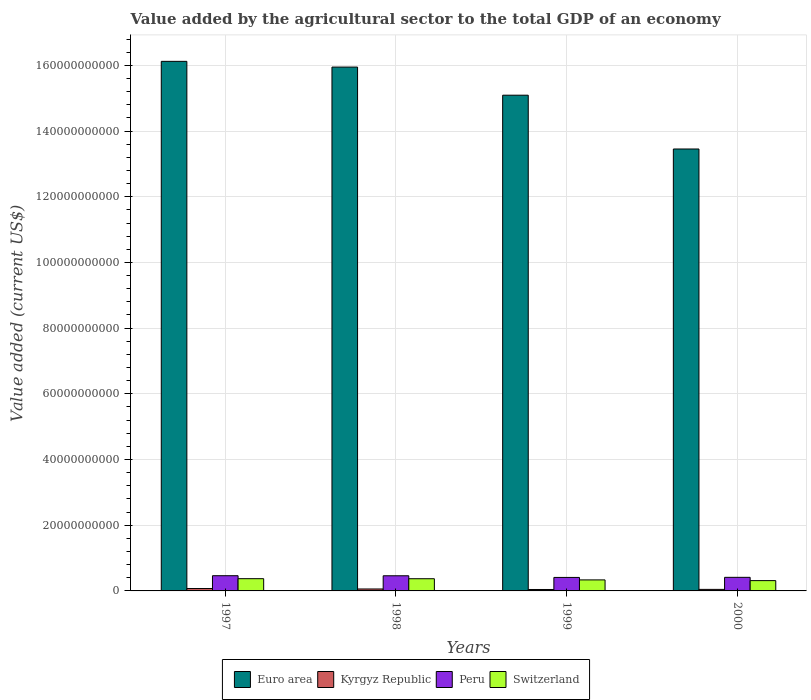How many different coloured bars are there?
Provide a short and direct response. 4. How many groups of bars are there?
Your answer should be very brief. 4. Are the number of bars on each tick of the X-axis equal?
Your answer should be compact. Yes. How many bars are there on the 4th tick from the right?
Make the answer very short. 4. What is the value added by the agricultural sector to the total GDP in Peru in 1998?
Ensure brevity in your answer.  4.61e+09. Across all years, what is the maximum value added by the agricultural sector to the total GDP in Kyrgyz Republic?
Offer a very short reply. 7.28e+08. Across all years, what is the minimum value added by the agricultural sector to the total GDP in Kyrgyz Republic?
Your response must be concise. 4.36e+08. What is the total value added by the agricultural sector to the total GDP in Kyrgyz Republic in the graph?
Give a very brief answer. 2.23e+09. What is the difference between the value added by the agricultural sector to the total GDP in Euro area in 1997 and that in 2000?
Provide a succinct answer. 2.67e+1. What is the difference between the value added by the agricultural sector to the total GDP in Kyrgyz Republic in 2000 and the value added by the agricultural sector to the total GDP in Peru in 1998?
Keep it short and to the point. -4.14e+09. What is the average value added by the agricultural sector to the total GDP in Euro area per year?
Your response must be concise. 1.52e+11. In the year 2000, what is the difference between the value added by the agricultural sector to the total GDP in Euro area and value added by the agricultural sector to the total GDP in Kyrgyz Republic?
Ensure brevity in your answer.  1.34e+11. What is the ratio of the value added by the agricultural sector to the total GDP in Kyrgyz Republic in 1998 to that in 1999?
Your response must be concise. 1.36. Is the value added by the agricultural sector to the total GDP in Peru in 1997 less than that in 1998?
Keep it short and to the point. No. What is the difference between the highest and the second highest value added by the agricultural sector to the total GDP in Switzerland?
Ensure brevity in your answer.  1.48e+07. What is the difference between the highest and the lowest value added by the agricultural sector to the total GDP in Peru?
Make the answer very short. 5.26e+08. In how many years, is the value added by the agricultural sector to the total GDP in Euro area greater than the average value added by the agricultural sector to the total GDP in Euro area taken over all years?
Provide a short and direct response. 2. Is the sum of the value added by the agricultural sector to the total GDP in Switzerland in 1997 and 1998 greater than the maximum value added by the agricultural sector to the total GDP in Euro area across all years?
Your answer should be very brief. No. Is it the case that in every year, the sum of the value added by the agricultural sector to the total GDP in Kyrgyz Republic and value added by the agricultural sector to the total GDP in Switzerland is greater than the sum of value added by the agricultural sector to the total GDP in Euro area and value added by the agricultural sector to the total GDP in Peru?
Provide a short and direct response. Yes. What does the 2nd bar from the left in 1999 represents?
Make the answer very short. Kyrgyz Republic. What does the 3rd bar from the right in 1997 represents?
Offer a terse response. Kyrgyz Republic. Is it the case that in every year, the sum of the value added by the agricultural sector to the total GDP in Switzerland and value added by the agricultural sector to the total GDP in Euro area is greater than the value added by the agricultural sector to the total GDP in Kyrgyz Republic?
Offer a very short reply. Yes. How many bars are there?
Keep it short and to the point. 16. Are the values on the major ticks of Y-axis written in scientific E-notation?
Your answer should be compact. No. Does the graph contain any zero values?
Your answer should be very brief. No. Does the graph contain grids?
Ensure brevity in your answer.  Yes. How many legend labels are there?
Provide a succinct answer. 4. What is the title of the graph?
Offer a very short reply. Value added by the agricultural sector to the total GDP of an economy. Does "Guatemala" appear as one of the legend labels in the graph?
Make the answer very short. No. What is the label or title of the X-axis?
Make the answer very short. Years. What is the label or title of the Y-axis?
Keep it short and to the point. Value added (current US$). What is the Value added (current US$) of Euro area in 1997?
Keep it short and to the point. 1.61e+11. What is the Value added (current US$) in Kyrgyz Republic in 1997?
Your response must be concise. 7.28e+08. What is the Value added (current US$) of Peru in 1997?
Offer a very short reply. 4.63e+09. What is the Value added (current US$) in Switzerland in 1997?
Provide a succinct answer. 3.73e+09. What is the Value added (current US$) of Euro area in 1998?
Keep it short and to the point. 1.59e+11. What is the Value added (current US$) of Kyrgyz Republic in 1998?
Give a very brief answer. 5.93e+08. What is the Value added (current US$) in Peru in 1998?
Your response must be concise. 4.61e+09. What is the Value added (current US$) in Switzerland in 1998?
Offer a terse response. 3.71e+09. What is the Value added (current US$) in Euro area in 1999?
Give a very brief answer. 1.51e+11. What is the Value added (current US$) in Kyrgyz Republic in 1999?
Give a very brief answer. 4.36e+08. What is the Value added (current US$) of Peru in 1999?
Your answer should be very brief. 4.11e+09. What is the Value added (current US$) in Switzerland in 1999?
Provide a short and direct response. 3.36e+09. What is the Value added (current US$) of Euro area in 2000?
Make the answer very short. 1.35e+11. What is the Value added (current US$) in Kyrgyz Republic in 2000?
Your answer should be compact. 4.68e+08. What is the Value added (current US$) of Peru in 2000?
Your response must be concise. 4.14e+09. What is the Value added (current US$) of Switzerland in 2000?
Your response must be concise. 3.14e+09. Across all years, what is the maximum Value added (current US$) in Euro area?
Ensure brevity in your answer.  1.61e+11. Across all years, what is the maximum Value added (current US$) in Kyrgyz Republic?
Offer a very short reply. 7.28e+08. Across all years, what is the maximum Value added (current US$) in Peru?
Provide a succinct answer. 4.63e+09. Across all years, what is the maximum Value added (current US$) of Switzerland?
Offer a terse response. 3.73e+09. Across all years, what is the minimum Value added (current US$) of Euro area?
Make the answer very short. 1.35e+11. Across all years, what is the minimum Value added (current US$) in Kyrgyz Republic?
Keep it short and to the point. 4.36e+08. Across all years, what is the minimum Value added (current US$) in Peru?
Provide a short and direct response. 4.11e+09. Across all years, what is the minimum Value added (current US$) of Switzerland?
Keep it short and to the point. 3.14e+09. What is the total Value added (current US$) in Euro area in the graph?
Offer a very short reply. 6.06e+11. What is the total Value added (current US$) of Kyrgyz Republic in the graph?
Your answer should be very brief. 2.23e+09. What is the total Value added (current US$) of Peru in the graph?
Offer a very short reply. 1.75e+1. What is the total Value added (current US$) in Switzerland in the graph?
Provide a succinct answer. 1.39e+1. What is the difference between the Value added (current US$) in Euro area in 1997 and that in 1998?
Give a very brief answer. 1.74e+09. What is the difference between the Value added (current US$) of Kyrgyz Republic in 1997 and that in 1998?
Your answer should be very brief. 1.35e+08. What is the difference between the Value added (current US$) in Peru in 1997 and that in 1998?
Keep it short and to the point. 2.03e+07. What is the difference between the Value added (current US$) in Switzerland in 1997 and that in 1998?
Keep it short and to the point. 1.48e+07. What is the difference between the Value added (current US$) in Euro area in 1997 and that in 1999?
Your answer should be very brief. 1.03e+1. What is the difference between the Value added (current US$) of Kyrgyz Republic in 1997 and that in 1999?
Ensure brevity in your answer.  2.92e+08. What is the difference between the Value added (current US$) of Peru in 1997 and that in 1999?
Offer a terse response. 5.26e+08. What is the difference between the Value added (current US$) of Switzerland in 1997 and that in 1999?
Your answer should be compact. 3.72e+08. What is the difference between the Value added (current US$) of Euro area in 1997 and that in 2000?
Keep it short and to the point. 2.67e+1. What is the difference between the Value added (current US$) of Kyrgyz Republic in 1997 and that in 2000?
Your response must be concise. 2.60e+08. What is the difference between the Value added (current US$) in Peru in 1997 and that in 2000?
Provide a succinct answer. 4.95e+08. What is the difference between the Value added (current US$) in Switzerland in 1997 and that in 2000?
Your answer should be very brief. 5.89e+08. What is the difference between the Value added (current US$) in Euro area in 1998 and that in 1999?
Your answer should be very brief. 8.56e+09. What is the difference between the Value added (current US$) in Kyrgyz Republic in 1998 and that in 1999?
Your response must be concise. 1.58e+08. What is the difference between the Value added (current US$) in Peru in 1998 and that in 1999?
Provide a succinct answer. 5.05e+08. What is the difference between the Value added (current US$) of Switzerland in 1998 and that in 1999?
Offer a terse response. 3.58e+08. What is the difference between the Value added (current US$) of Euro area in 1998 and that in 2000?
Provide a succinct answer. 2.49e+1. What is the difference between the Value added (current US$) in Kyrgyz Republic in 1998 and that in 2000?
Keep it short and to the point. 1.25e+08. What is the difference between the Value added (current US$) in Peru in 1998 and that in 2000?
Keep it short and to the point. 4.74e+08. What is the difference between the Value added (current US$) of Switzerland in 1998 and that in 2000?
Make the answer very short. 5.74e+08. What is the difference between the Value added (current US$) of Euro area in 1999 and that in 2000?
Keep it short and to the point. 1.64e+1. What is the difference between the Value added (current US$) in Kyrgyz Republic in 1999 and that in 2000?
Provide a short and direct response. -3.26e+07. What is the difference between the Value added (current US$) in Peru in 1999 and that in 2000?
Your answer should be compact. -3.11e+07. What is the difference between the Value added (current US$) in Switzerland in 1999 and that in 2000?
Ensure brevity in your answer.  2.17e+08. What is the difference between the Value added (current US$) in Euro area in 1997 and the Value added (current US$) in Kyrgyz Republic in 1998?
Your answer should be very brief. 1.61e+11. What is the difference between the Value added (current US$) of Euro area in 1997 and the Value added (current US$) of Peru in 1998?
Your answer should be very brief. 1.57e+11. What is the difference between the Value added (current US$) in Euro area in 1997 and the Value added (current US$) in Switzerland in 1998?
Your response must be concise. 1.58e+11. What is the difference between the Value added (current US$) in Kyrgyz Republic in 1997 and the Value added (current US$) in Peru in 1998?
Offer a very short reply. -3.88e+09. What is the difference between the Value added (current US$) in Kyrgyz Republic in 1997 and the Value added (current US$) in Switzerland in 1998?
Keep it short and to the point. -2.98e+09. What is the difference between the Value added (current US$) of Peru in 1997 and the Value added (current US$) of Switzerland in 1998?
Offer a very short reply. 9.19e+08. What is the difference between the Value added (current US$) in Euro area in 1997 and the Value added (current US$) in Kyrgyz Republic in 1999?
Give a very brief answer. 1.61e+11. What is the difference between the Value added (current US$) of Euro area in 1997 and the Value added (current US$) of Peru in 1999?
Make the answer very short. 1.57e+11. What is the difference between the Value added (current US$) in Euro area in 1997 and the Value added (current US$) in Switzerland in 1999?
Your answer should be compact. 1.58e+11. What is the difference between the Value added (current US$) in Kyrgyz Republic in 1997 and the Value added (current US$) in Peru in 1999?
Make the answer very short. -3.38e+09. What is the difference between the Value added (current US$) of Kyrgyz Republic in 1997 and the Value added (current US$) of Switzerland in 1999?
Provide a short and direct response. -2.63e+09. What is the difference between the Value added (current US$) in Peru in 1997 and the Value added (current US$) in Switzerland in 1999?
Provide a short and direct response. 1.28e+09. What is the difference between the Value added (current US$) in Euro area in 1997 and the Value added (current US$) in Kyrgyz Republic in 2000?
Provide a succinct answer. 1.61e+11. What is the difference between the Value added (current US$) in Euro area in 1997 and the Value added (current US$) in Peru in 2000?
Make the answer very short. 1.57e+11. What is the difference between the Value added (current US$) in Euro area in 1997 and the Value added (current US$) in Switzerland in 2000?
Offer a very short reply. 1.58e+11. What is the difference between the Value added (current US$) of Kyrgyz Republic in 1997 and the Value added (current US$) of Peru in 2000?
Provide a succinct answer. -3.41e+09. What is the difference between the Value added (current US$) in Kyrgyz Republic in 1997 and the Value added (current US$) in Switzerland in 2000?
Make the answer very short. -2.41e+09. What is the difference between the Value added (current US$) of Peru in 1997 and the Value added (current US$) of Switzerland in 2000?
Your response must be concise. 1.49e+09. What is the difference between the Value added (current US$) of Euro area in 1998 and the Value added (current US$) of Kyrgyz Republic in 1999?
Offer a terse response. 1.59e+11. What is the difference between the Value added (current US$) in Euro area in 1998 and the Value added (current US$) in Peru in 1999?
Keep it short and to the point. 1.55e+11. What is the difference between the Value added (current US$) of Euro area in 1998 and the Value added (current US$) of Switzerland in 1999?
Provide a succinct answer. 1.56e+11. What is the difference between the Value added (current US$) of Kyrgyz Republic in 1998 and the Value added (current US$) of Peru in 1999?
Your response must be concise. -3.51e+09. What is the difference between the Value added (current US$) in Kyrgyz Republic in 1998 and the Value added (current US$) in Switzerland in 1999?
Offer a terse response. -2.76e+09. What is the difference between the Value added (current US$) of Peru in 1998 and the Value added (current US$) of Switzerland in 1999?
Make the answer very short. 1.26e+09. What is the difference between the Value added (current US$) of Euro area in 1998 and the Value added (current US$) of Kyrgyz Republic in 2000?
Your answer should be compact. 1.59e+11. What is the difference between the Value added (current US$) in Euro area in 1998 and the Value added (current US$) in Peru in 2000?
Offer a very short reply. 1.55e+11. What is the difference between the Value added (current US$) of Euro area in 1998 and the Value added (current US$) of Switzerland in 2000?
Offer a very short reply. 1.56e+11. What is the difference between the Value added (current US$) of Kyrgyz Republic in 1998 and the Value added (current US$) of Peru in 2000?
Provide a succinct answer. -3.54e+09. What is the difference between the Value added (current US$) of Kyrgyz Republic in 1998 and the Value added (current US$) of Switzerland in 2000?
Your answer should be compact. -2.55e+09. What is the difference between the Value added (current US$) of Peru in 1998 and the Value added (current US$) of Switzerland in 2000?
Provide a succinct answer. 1.47e+09. What is the difference between the Value added (current US$) in Euro area in 1999 and the Value added (current US$) in Kyrgyz Republic in 2000?
Your response must be concise. 1.50e+11. What is the difference between the Value added (current US$) of Euro area in 1999 and the Value added (current US$) of Peru in 2000?
Your response must be concise. 1.47e+11. What is the difference between the Value added (current US$) of Euro area in 1999 and the Value added (current US$) of Switzerland in 2000?
Make the answer very short. 1.48e+11. What is the difference between the Value added (current US$) of Kyrgyz Republic in 1999 and the Value added (current US$) of Peru in 2000?
Give a very brief answer. -3.70e+09. What is the difference between the Value added (current US$) of Kyrgyz Republic in 1999 and the Value added (current US$) of Switzerland in 2000?
Make the answer very short. -2.70e+09. What is the difference between the Value added (current US$) of Peru in 1999 and the Value added (current US$) of Switzerland in 2000?
Offer a very short reply. 9.68e+08. What is the average Value added (current US$) in Euro area per year?
Your answer should be very brief. 1.52e+11. What is the average Value added (current US$) in Kyrgyz Republic per year?
Ensure brevity in your answer.  5.56e+08. What is the average Value added (current US$) in Peru per year?
Give a very brief answer. 4.37e+09. What is the average Value added (current US$) of Switzerland per year?
Ensure brevity in your answer.  3.48e+09. In the year 1997, what is the difference between the Value added (current US$) of Euro area and Value added (current US$) of Kyrgyz Republic?
Provide a succinct answer. 1.60e+11. In the year 1997, what is the difference between the Value added (current US$) in Euro area and Value added (current US$) in Peru?
Provide a succinct answer. 1.57e+11. In the year 1997, what is the difference between the Value added (current US$) of Euro area and Value added (current US$) of Switzerland?
Give a very brief answer. 1.57e+11. In the year 1997, what is the difference between the Value added (current US$) of Kyrgyz Republic and Value added (current US$) of Peru?
Your answer should be compact. -3.90e+09. In the year 1997, what is the difference between the Value added (current US$) of Kyrgyz Republic and Value added (current US$) of Switzerland?
Provide a succinct answer. -3.00e+09. In the year 1997, what is the difference between the Value added (current US$) of Peru and Value added (current US$) of Switzerland?
Keep it short and to the point. 9.05e+08. In the year 1998, what is the difference between the Value added (current US$) in Euro area and Value added (current US$) in Kyrgyz Republic?
Offer a very short reply. 1.59e+11. In the year 1998, what is the difference between the Value added (current US$) in Euro area and Value added (current US$) in Peru?
Provide a succinct answer. 1.55e+11. In the year 1998, what is the difference between the Value added (current US$) of Euro area and Value added (current US$) of Switzerland?
Provide a succinct answer. 1.56e+11. In the year 1998, what is the difference between the Value added (current US$) in Kyrgyz Republic and Value added (current US$) in Peru?
Give a very brief answer. -4.02e+09. In the year 1998, what is the difference between the Value added (current US$) of Kyrgyz Republic and Value added (current US$) of Switzerland?
Your response must be concise. -3.12e+09. In the year 1998, what is the difference between the Value added (current US$) of Peru and Value added (current US$) of Switzerland?
Provide a short and direct response. 8.99e+08. In the year 1999, what is the difference between the Value added (current US$) in Euro area and Value added (current US$) in Kyrgyz Republic?
Your response must be concise. 1.50e+11. In the year 1999, what is the difference between the Value added (current US$) in Euro area and Value added (current US$) in Peru?
Give a very brief answer. 1.47e+11. In the year 1999, what is the difference between the Value added (current US$) of Euro area and Value added (current US$) of Switzerland?
Provide a short and direct response. 1.48e+11. In the year 1999, what is the difference between the Value added (current US$) of Kyrgyz Republic and Value added (current US$) of Peru?
Provide a succinct answer. -3.67e+09. In the year 1999, what is the difference between the Value added (current US$) of Kyrgyz Republic and Value added (current US$) of Switzerland?
Provide a succinct answer. -2.92e+09. In the year 1999, what is the difference between the Value added (current US$) of Peru and Value added (current US$) of Switzerland?
Ensure brevity in your answer.  7.51e+08. In the year 2000, what is the difference between the Value added (current US$) in Euro area and Value added (current US$) in Kyrgyz Republic?
Give a very brief answer. 1.34e+11. In the year 2000, what is the difference between the Value added (current US$) of Euro area and Value added (current US$) of Peru?
Give a very brief answer. 1.30e+11. In the year 2000, what is the difference between the Value added (current US$) in Euro area and Value added (current US$) in Switzerland?
Keep it short and to the point. 1.31e+11. In the year 2000, what is the difference between the Value added (current US$) of Kyrgyz Republic and Value added (current US$) of Peru?
Provide a succinct answer. -3.67e+09. In the year 2000, what is the difference between the Value added (current US$) in Kyrgyz Republic and Value added (current US$) in Switzerland?
Make the answer very short. -2.67e+09. In the year 2000, what is the difference between the Value added (current US$) of Peru and Value added (current US$) of Switzerland?
Offer a terse response. 9.99e+08. What is the ratio of the Value added (current US$) in Euro area in 1997 to that in 1998?
Your answer should be very brief. 1.01. What is the ratio of the Value added (current US$) of Kyrgyz Republic in 1997 to that in 1998?
Provide a short and direct response. 1.23. What is the ratio of the Value added (current US$) of Euro area in 1997 to that in 1999?
Your answer should be compact. 1.07. What is the ratio of the Value added (current US$) of Kyrgyz Republic in 1997 to that in 1999?
Provide a succinct answer. 1.67. What is the ratio of the Value added (current US$) in Peru in 1997 to that in 1999?
Ensure brevity in your answer.  1.13. What is the ratio of the Value added (current US$) in Switzerland in 1997 to that in 1999?
Your response must be concise. 1.11. What is the ratio of the Value added (current US$) of Euro area in 1997 to that in 2000?
Ensure brevity in your answer.  1.2. What is the ratio of the Value added (current US$) in Kyrgyz Republic in 1997 to that in 2000?
Your answer should be very brief. 1.55. What is the ratio of the Value added (current US$) in Peru in 1997 to that in 2000?
Your answer should be very brief. 1.12. What is the ratio of the Value added (current US$) of Switzerland in 1997 to that in 2000?
Make the answer very short. 1.19. What is the ratio of the Value added (current US$) in Euro area in 1998 to that in 1999?
Give a very brief answer. 1.06. What is the ratio of the Value added (current US$) in Kyrgyz Republic in 1998 to that in 1999?
Give a very brief answer. 1.36. What is the ratio of the Value added (current US$) in Peru in 1998 to that in 1999?
Keep it short and to the point. 1.12. What is the ratio of the Value added (current US$) in Switzerland in 1998 to that in 1999?
Your answer should be compact. 1.11. What is the ratio of the Value added (current US$) in Euro area in 1998 to that in 2000?
Offer a very short reply. 1.19. What is the ratio of the Value added (current US$) in Kyrgyz Republic in 1998 to that in 2000?
Offer a terse response. 1.27. What is the ratio of the Value added (current US$) of Peru in 1998 to that in 2000?
Your response must be concise. 1.11. What is the ratio of the Value added (current US$) in Switzerland in 1998 to that in 2000?
Your answer should be very brief. 1.18. What is the ratio of the Value added (current US$) of Euro area in 1999 to that in 2000?
Keep it short and to the point. 1.12. What is the ratio of the Value added (current US$) in Kyrgyz Republic in 1999 to that in 2000?
Offer a very short reply. 0.93. What is the ratio of the Value added (current US$) in Switzerland in 1999 to that in 2000?
Ensure brevity in your answer.  1.07. What is the difference between the highest and the second highest Value added (current US$) in Euro area?
Provide a short and direct response. 1.74e+09. What is the difference between the highest and the second highest Value added (current US$) in Kyrgyz Republic?
Your response must be concise. 1.35e+08. What is the difference between the highest and the second highest Value added (current US$) in Peru?
Provide a short and direct response. 2.03e+07. What is the difference between the highest and the second highest Value added (current US$) in Switzerland?
Provide a succinct answer. 1.48e+07. What is the difference between the highest and the lowest Value added (current US$) of Euro area?
Your answer should be very brief. 2.67e+1. What is the difference between the highest and the lowest Value added (current US$) in Kyrgyz Republic?
Your answer should be very brief. 2.92e+08. What is the difference between the highest and the lowest Value added (current US$) of Peru?
Provide a short and direct response. 5.26e+08. What is the difference between the highest and the lowest Value added (current US$) of Switzerland?
Keep it short and to the point. 5.89e+08. 